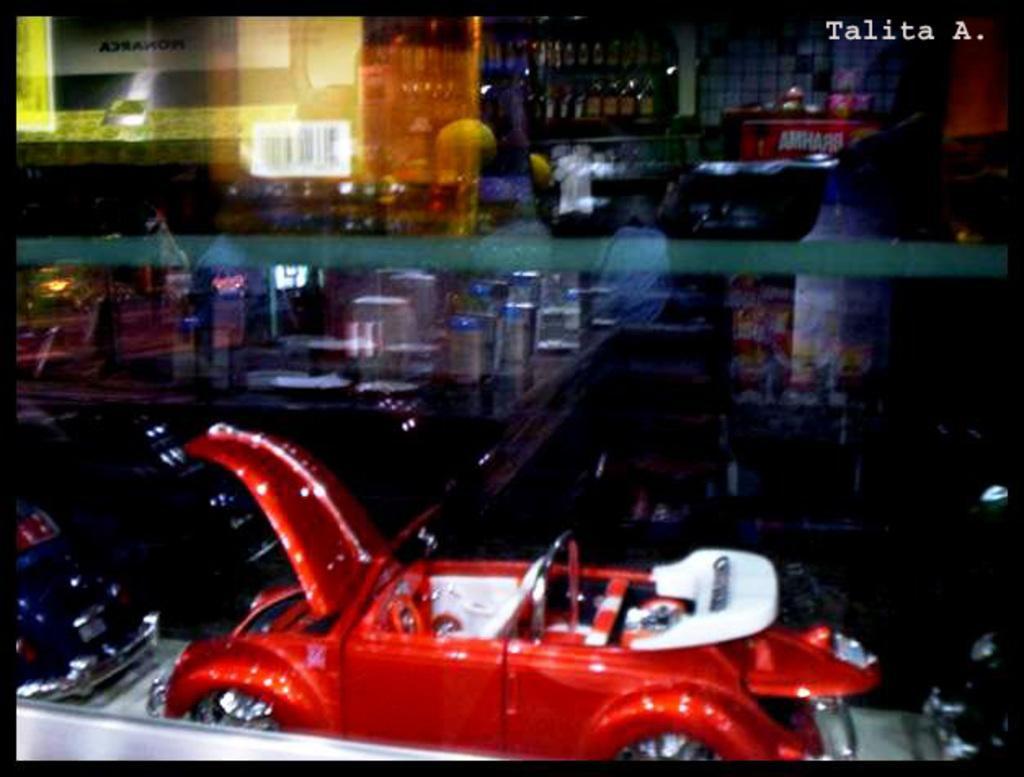Describe this image in one or two sentences. In the foreground of the picture I can see the glass window. I can see the toy cars at the bottom of the picture. I can see the alcohol bottles on the shelf at the top of the picture. 